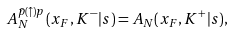Convert formula to latex. <formula><loc_0><loc_0><loc_500><loc_500>A _ { N } ^ { \bar { p } ( \uparrow ) p } ( x _ { F } , K ^ { - } | s ) = A _ { N } ( x _ { F } , K ^ { + } | s ) ,</formula> 